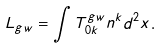Convert formula to latex. <formula><loc_0><loc_0><loc_500><loc_500>L _ { g w } = \int T _ { 0 k } ^ { g w } n ^ { k } d ^ { 2 } x .</formula> 